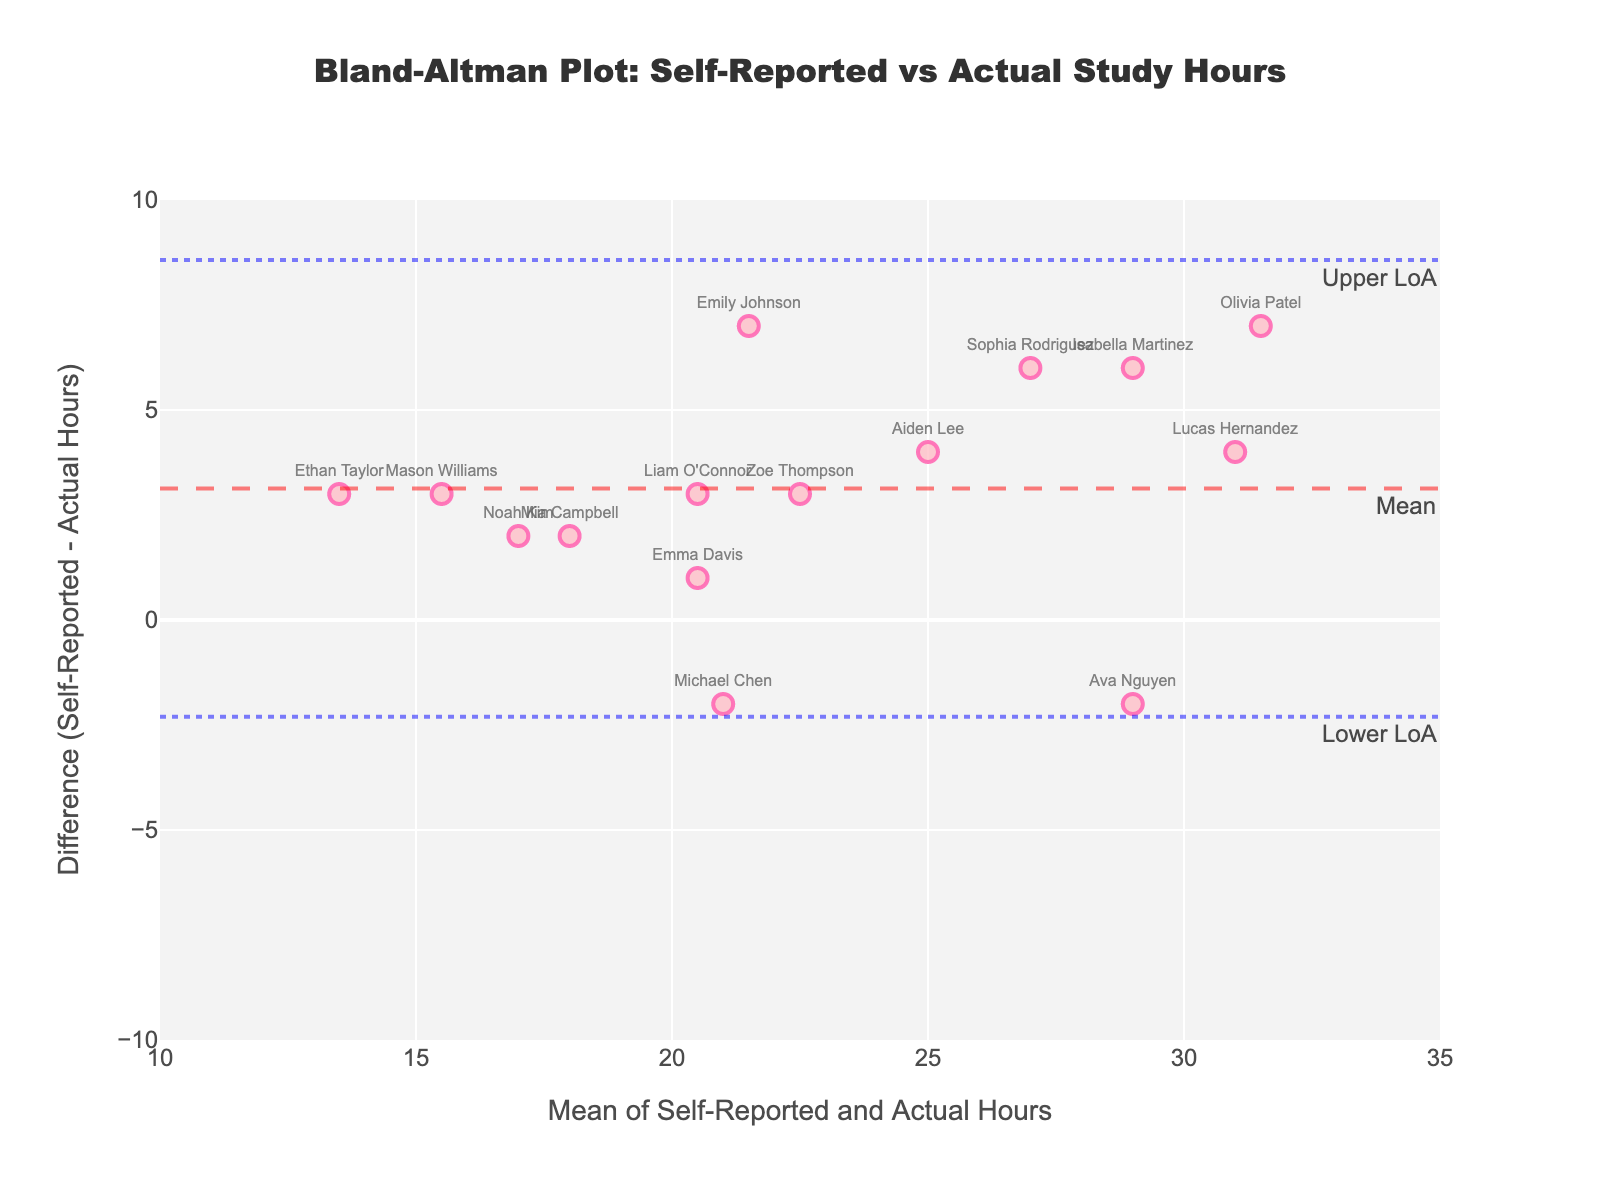How many students are represented in the plot? Count all the individual data points on the plot, each labeled with a student's name.
Answer: 15 What is the title of the plot? Look at the top center of the plot where the title is displayed.
Answer: Bland-Altman Plot: Self-Reported vs Actual Study Hours What do the x-axis and y-axis represent? The x-axis represents the mean of self-reported and actual hours, while the y-axis represents the difference between self-reported and actual hours. The axes labels indicate this.
Answer: x-axis: Mean of Self-Reported and Actual Hours, y-axis: Difference (Self-Reported - Actual Hours) What does the dashed horizontal line represent? This line represents the mean difference between self-reported and actual hours. Look for the line labeled "Mean" with a dashed annotation.
Answer: Mean difference What do the dotted horizontal lines indicate? These lines represent the limits of agreement (both lower and upper limits). Look for lines labeled "Lower LoA" and "Upper LoA" with dotted annotations.
Answer: Limits of agreement Which student reported the highest self-reported study hours and what was the actual hours? Identify the student whose data point is farthest to the right, which represents the highest mean value. Verify with the actual hours on the y-axis. This is based on the extreme student labeled on the right side.
Answer: Lucas Hernandez, 29 hours What is the range of the difference between self-reported and actual study hours? Look at the y-axis to find the highest and lowest points that represent the differences.
Answer: -7 to 7 Who is the student with the largest over-reported study hours? Identify the data point with the highest positive value on the y-axis, labeled with the student's name.
Answer: Olivia Patel What is the mean difference in study hours between self-reported and actual values? Find the horizontal dashed line labeled "Mean" to determine the mean difference value.
Answer: 1.6 How many students reported studying more hours than they actually did? Count the number of data points above the y=0 line, as these indicate an over-report in study hours.
Answer: 9 